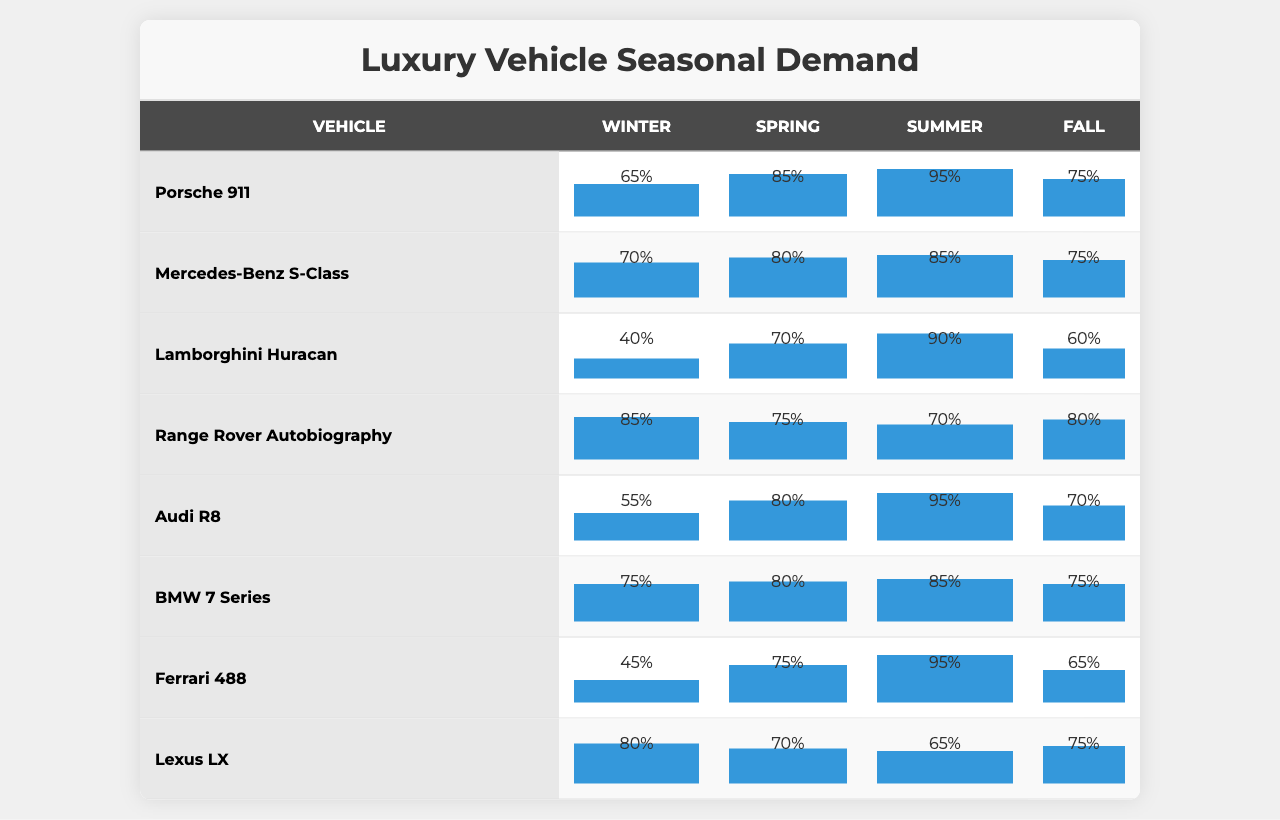What is the demand for the Porsche 911 in the Summer? The table shows that the demand for the Porsche 911 in the Summer is listed as 95%.
Answer: 95% Which vehicle has the highest demand during Winter? By examining the Winter column, the Range Rover Autobiography has the highest demand at 85%.
Answer: Range Rover Autobiography What is the average demand for the Mercedes-Benz S-Class across all seasons? The demands for the Mercedes-Benz S-Class are Winter (70), Spring (80), Summer (85), and Fall (75). The sum is 70 + 80 + 85 + 75 = 310. Therefore, the average is 310/4 = 77.5.
Answer: 77.5 Is the demand for the Lamborghini Huracan greater in Spring than in Fall? In the Spring, the demand is recorded as 70%, while in the Fall, it is 60%. Since 70% is greater than 60%, the statement is true.
Answer: Yes Which vehicle shows the least fluctuation in demand across the seasons? By analyzing the demand percentages for each vehicle, the one with the smallest difference between the highest demand (95%) and the lowest demand (65%) is the Audi R8 (55% in Winter and 95% in Summer, difference of 40). The BMW 7 Series also shows a difference of 10% but stays more stable (75% to 85%). However, BMW shows a lower range change, hence it has the least fluctuation.
Answer: BMW 7 Series What is the total demand for all vehicles combined in Fall? The total demand in Fall can be calculated by adding the Fall demands: 75 (Porsche) + 75 (Mercedes) + 60 (Lamborghini) + 80 (Range Rover) + 70 (Audi) + 75 (BMW) + 65 (Ferrari) + 75 (Lexus) = 585.
Answer: 585 In which season is the demand for the Ferrari 488 the lowest? The demands for Ferrari 488 are Winter (45), Spring (75), Summer (95), and Fall (65). The lowest value is in Winter, with 45%.
Answer: Winter Which two vehicles have the exact same demand in Fall? Checking the Fall column reveals that the demand for the Porsche 911 and the Mercedes-Benz S-Class both have a value of 75%.
Answer: Porsche 911 and Mercedes-Benz S-Class What is the percentage difference in demand for the Audi R8 between Summer and Winter? The demand for Audi R8 in Winter is 55%, and in Summer, it is 95%. The percentage difference is calculated as (95 - 55) / 55 * 100, which equals approximately 72.73%.
Answer: 72.73% True or False: The demand for luxury vehicles tends to peak in Summer. By checking the Summer data across all vehicles, it is evident that several vehicles have their highest demands in Summer compared to other seasons, confirming the trend.
Answer: True 